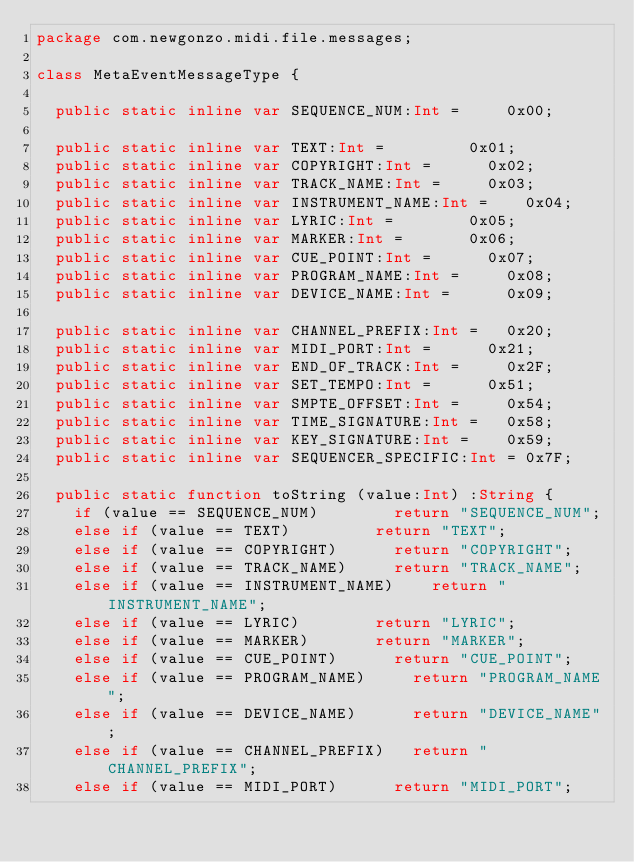Convert code to text. <code><loc_0><loc_0><loc_500><loc_500><_Haxe_>package com.newgonzo.midi.file.messages;

class MetaEventMessageType {
	
	public static inline var SEQUENCE_NUM:Int =			0x00;
	               
	public static inline var TEXT:Int =					0x01;
	public static inline var COPYRIGHT:Int =			0x02;
	public static inline var TRACK_NAME:Int =			0x03;
	public static inline var INSTRUMENT_NAME:Int =		0x04;
	public static inline var LYRIC:Int =				0x05;
	public static inline var MARKER:Int =				0x06;
	public static inline var CUE_POINT:Int =			0x07;
	public static inline var PROGRAM_NAME:Int =			0x08;
	public static inline var DEVICE_NAME:Int =			0x09;
	               
	public static inline var CHANNEL_PREFIX:Int =		0x20;
	public static inline var MIDI_PORT:Int =			0x21;
	public static inline var END_OF_TRACK:Int =			0x2F;
	public static inline var SET_TEMPO:Int =			0x51;
	public static inline var SMPTE_OFFSET:Int =			0x54;
	public static inline var TIME_SIGNATURE:Int =		0x58;
	public static inline var KEY_SIGNATURE:Int =		0x59;
	public static inline var SEQUENCER_SPECIFIC:Int =	0x7F;
	
	public static function toString (value:Int) :String {
		if (value == SEQUENCE_NUM)				return "SEQUENCE_NUM";
		else if (value == TEXT)					return "TEXT";
		else if (value == COPYRIGHT)			return "COPYRIGHT";
		else if (value == TRACK_NAME)			return "TRACK_NAME";
		else if (value == INSTRUMENT_NAME)		return "INSTRUMENT_NAME";
		else if (value == LYRIC)				return "LYRIC";
		else if (value == MARKER)				return "MARKER";
		else if (value == CUE_POINT)			return "CUE_POINT";
		else if (value == PROGRAM_NAME)			return "PROGRAM_NAME";
		else if (value == DEVICE_NAME)			return "DEVICE_NAME";
		else if (value == CHANNEL_PREFIX)		return "CHANNEL_PREFIX";
		else if (value == MIDI_PORT)			return "MIDI_PORT";</code> 